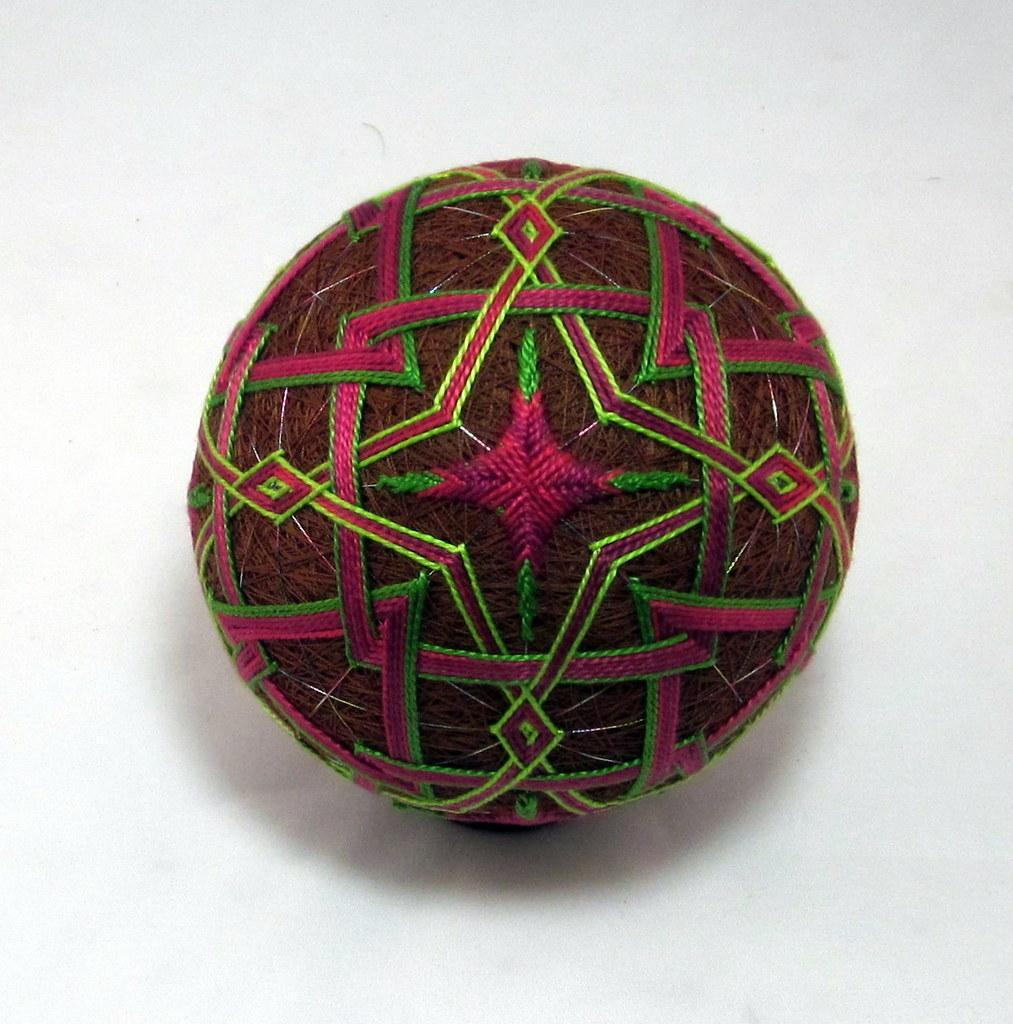What is the main subject of the image? The main subject of the image is a colorful thread ball. Can you describe the surface on which the thread ball is placed? The thread ball is on a white surface. What is the reason for the thread ball to be on the white surface in the image? There is no specific reason mentioned or implied in the image for the thread ball to be on the white surface. Can you see the arm of a person holding the thread ball in the image? There is no arm or person visible in the image. 